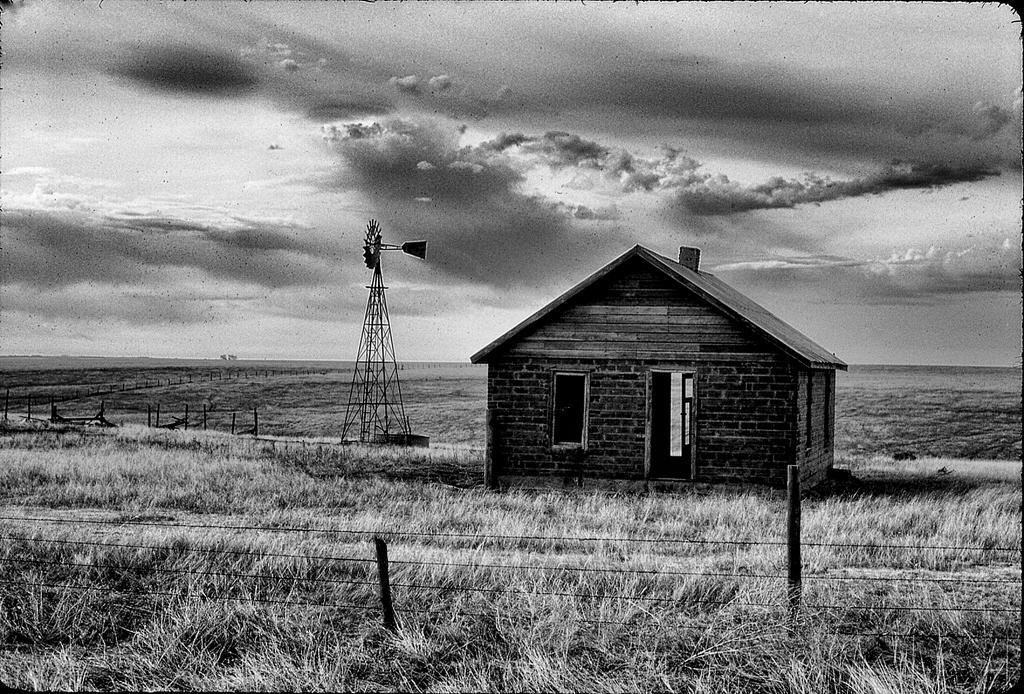Can you describe this image briefly? It is the black and white image in which there is a brick house in the middle. On the left side there is a windmill. There is a fence around the house. At the bottom there is grass. At the top there is the sky. 